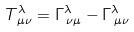<formula> <loc_0><loc_0><loc_500><loc_500>T ^ { \lambda } _ { \, \mu \nu } = \Gamma ^ { \lambda } _ { \, \nu \mu } - \Gamma ^ { \lambda } _ { \, \mu \nu }</formula> 